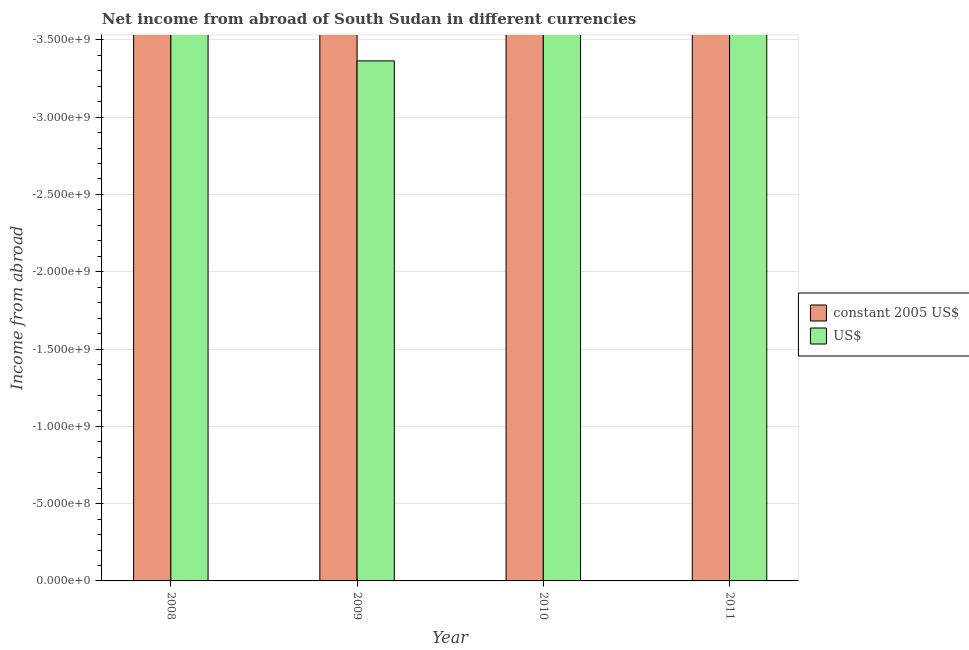How many different coloured bars are there?
Offer a very short reply. 0. How many bars are there on the 2nd tick from the left?
Your response must be concise. 0. In how many cases, is the number of bars for a given year not equal to the number of legend labels?
Your answer should be compact. 4. Across all years, what is the minimum income from abroad in us$?
Provide a short and direct response. 0. In how many years, is the income from abroad in us$ greater than -400000000 units?
Provide a short and direct response. 0. In how many years, is the income from abroad in constant 2005 us$ greater than the average income from abroad in constant 2005 us$ taken over all years?
Your answer should be compact. 0. How many bars are there?
Your answer should be very brief. 0. Are all the bars in the graph horizontal?
Offer a very short reply. No. What is the difference between two consecutive major ticks on the Y-axis?
Provide a succinct answer. 5.00e+08. Does the graph contain any zero values?
Provide a succinct answer. Yes. How are the legend labels stacked?
Offer a terse response. Vertical. What is the title of the graph?
Provide a short and direct response. Net income from abroad of South Sudan in different currencies. What is the label or title of the X-axis?
Your answer should be very brief. Year. What is the label or title of the Y-axis?
Your answer should be very brief. Income from abroad. What is the Income from abroad of constant 2005 US$ in 2008?
Provide a succinct answer. 0. What is the Income from abroad of US$ in 2009?
Offer a terse response. 0. What is the Income from abroad of constant 2005 US$ in 2010?
Your answer should be compact. 0. What is the total Income from abroad in constant 2005 US$ in the graph?
Give a very brief answer. 0. 